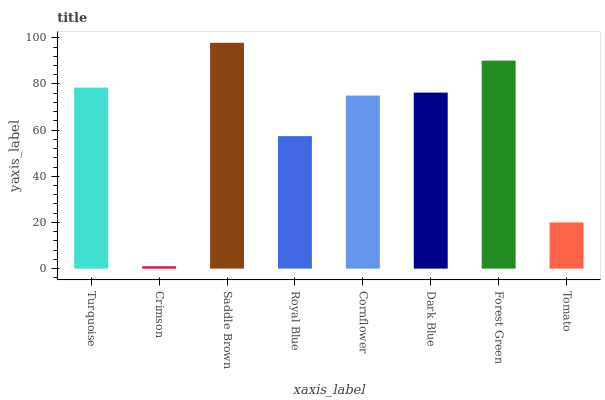Is Crimson the minimum?
Answer yes or no. Yes. Is Saddle Brown the maximum?
Answer yes or no. Yes. Is Saddle Brown the minimum?
Answer yes or no. No. Is Crimson the maximum?
Answer yes or no. No. Is Saddle Brown greater than Crimson?
Answer yes or no. Yes. Is Crimson less than Saddle Brown?
Answer yes or no. Yes. Is Crimson greater than Saddle Brown?
Answer yes or no. No. Is Saddle Brown less than Crimson?
Answer yes or no. No. Is Dark Blue the high median?
Answer yes or no. Yes. Is Cornflower the low median?
Answer yes or no. Yes. Is Royal Blue the high median?
Answer yes or no. No. Is Royal Blue the low median?
Answer yes or no. No. 